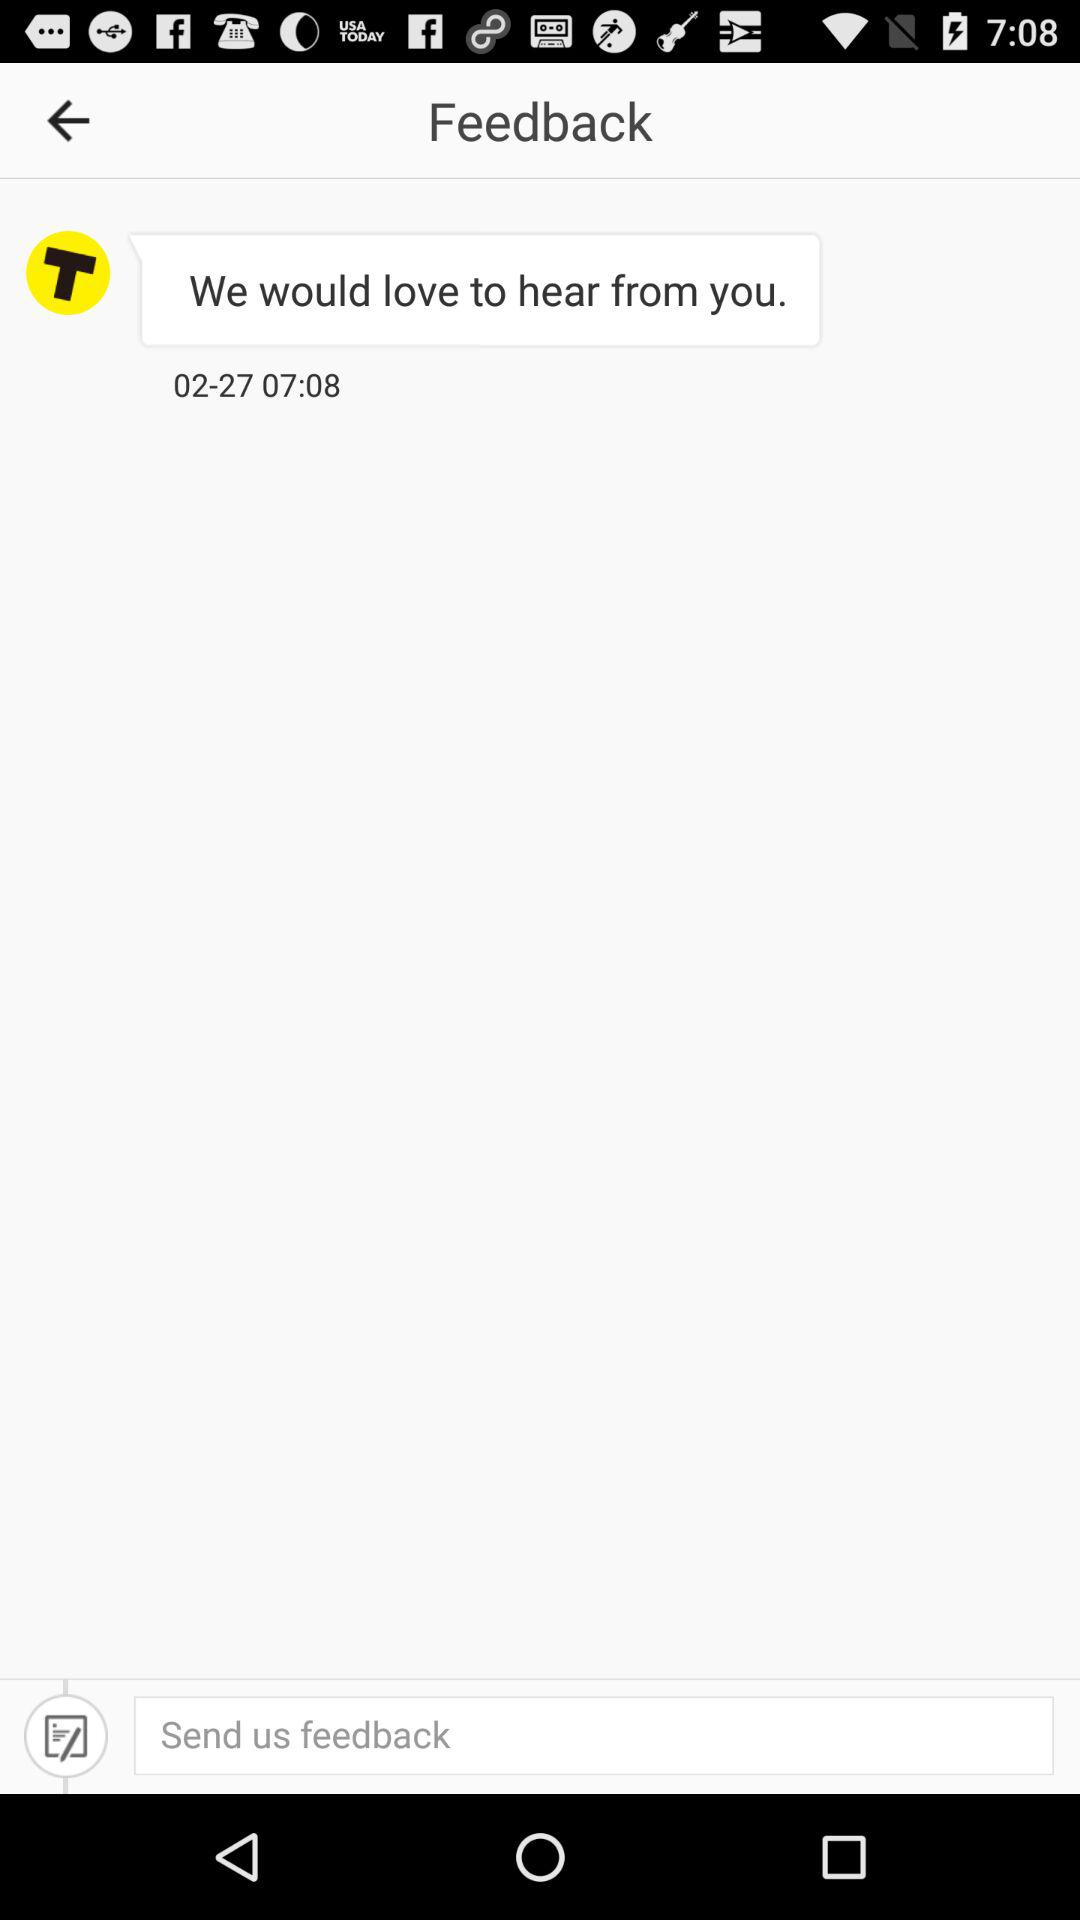What is the date of the feedback? The date of the feedback is February 27. 